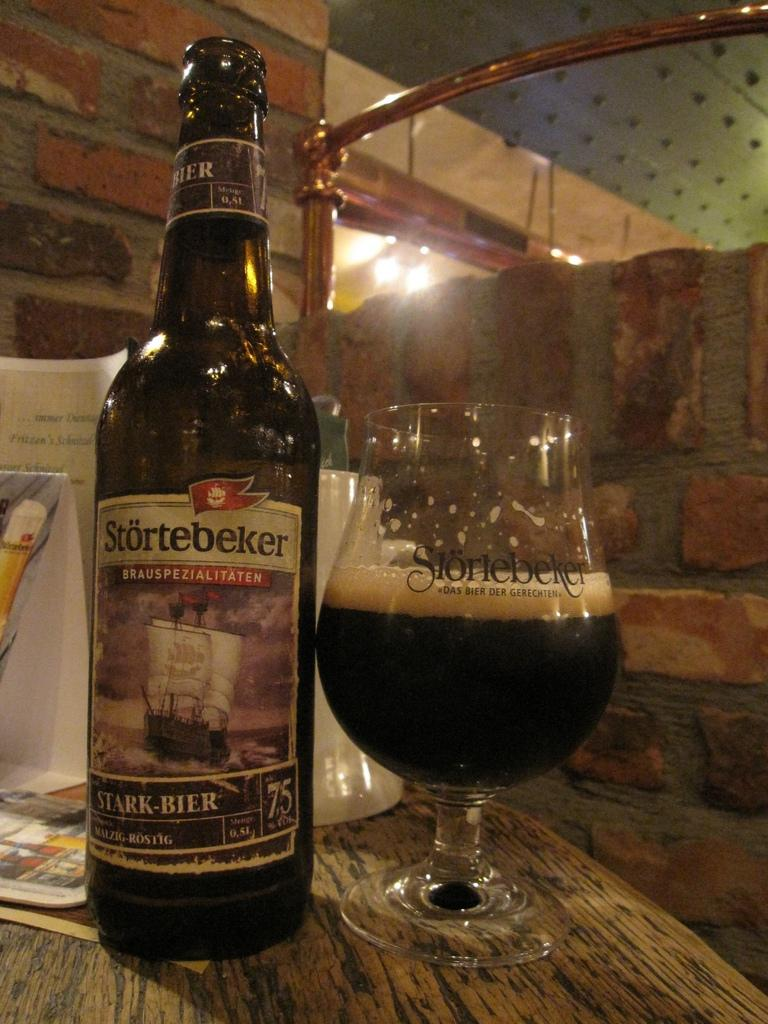Provide a one-sentence caption for the provided image. A bottle of dark beer named Stortebeker stands alongside a half glass of beer on a wooden table. 